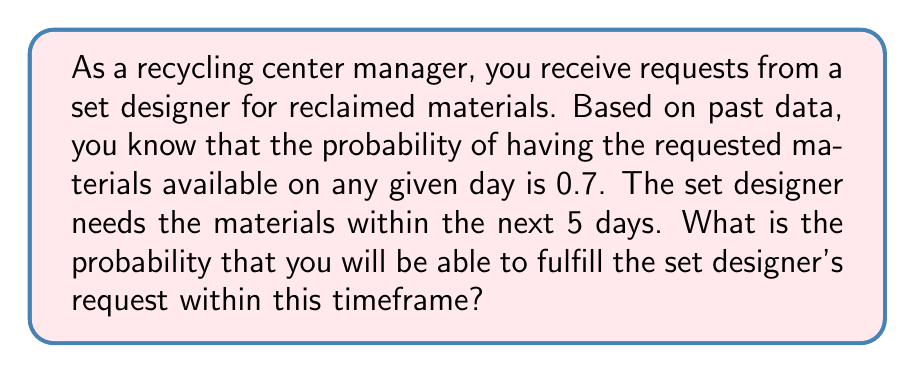Can you solve this math problem? To solve this problem, we need to use the concept of probability for independent events.

1) First, let's consider the probability of not having the materials on a single day:
   $P(\text{not available}) = 1 - 0.7 = 0.3$

2) For the request to not be fulfilled within 5 days, the materials would need to be unavailable on all 5 days. Since each day is independent, we multiply these probabilities:
   $P(\text{not fulfilled in 5 days}) = 0.3^5 = 0.00243$

3) Therefore, the probability of fulfilling the request within 5 days is the opposite of this:
   $P(\text{fulfilled in 5 days}) = 1 - P(\text{not fulfilled in 5 days})$
   $= 1 - 0.00243 = 0.99757$

4) We can also calculate this directly:
   $P(\text{fulfilled in 5 days}) = 1 - (1 - 0.7)^5 = 1 - 0.3^5 = 0.99757$

5) To express this as a percentage:
   $0.99757 \times 100\% = 99.757\%$

Thus, there is a 99.757% chance of fulfilling the set designer's request within 5 days.
Answer: The probability of fulfilling the set designer's request within 5 days is approximately 0.99757, or 99.757%. 